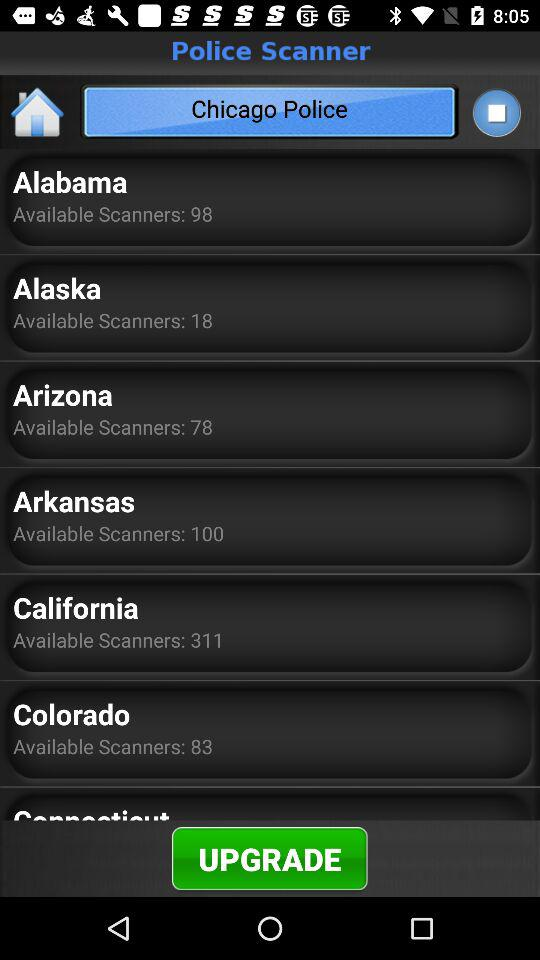In what state are 100 scanners available? 100 scanners are available in Arkansas. 